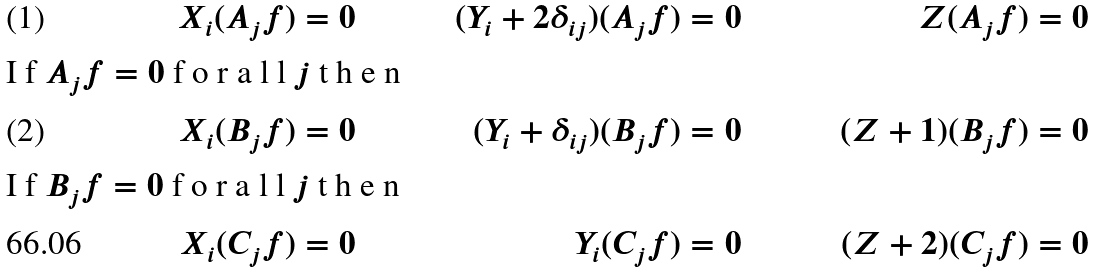<formula> <loc_0><loc_0><loc_500><loc_500>X _ { i } ( A _ { j } f ) & = 0 & ( Y _ { i } + 2 \delta _ { i j } ) ( A _ { j } f ) & = 0 & Z ( A _ { j } f ) & = 0 \intertext { I f $ A _ { j } f = 0 $ f o r a l l $ j $ t h e n } X _ { i } ( B _ { j } f ) & = 0 & ( Y _ { i } + \delta _ { i j } ) ( B _ { j } f ) & = 0 & ( Z + 1 ) ( B _ { j } f ) & = 0 \intertext { I f $ B _ { j } f = 0 $ f o r a l l $ j $ t h e n } X _ { i } ( C _ { j } f ) & = 0 & Y _ { i } ( C _ { j } f ) & = 0 & ( Z + 2 ) ( C _ { j } f ) & = 0</formula> 